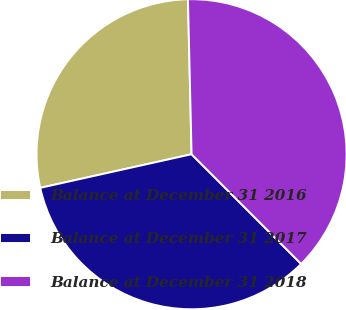Convert chart to OTSL. <chart><loc_0><loc_0><loc_500><loc_500><pie_chart><fcel>Balance at December 31 2016<fcel>Balance at December 31 2017<fcel>Balance at December 31 2018<nl><fcel>28.11%<fcel>34.01%<fcel>37.88%<nl></chart> 